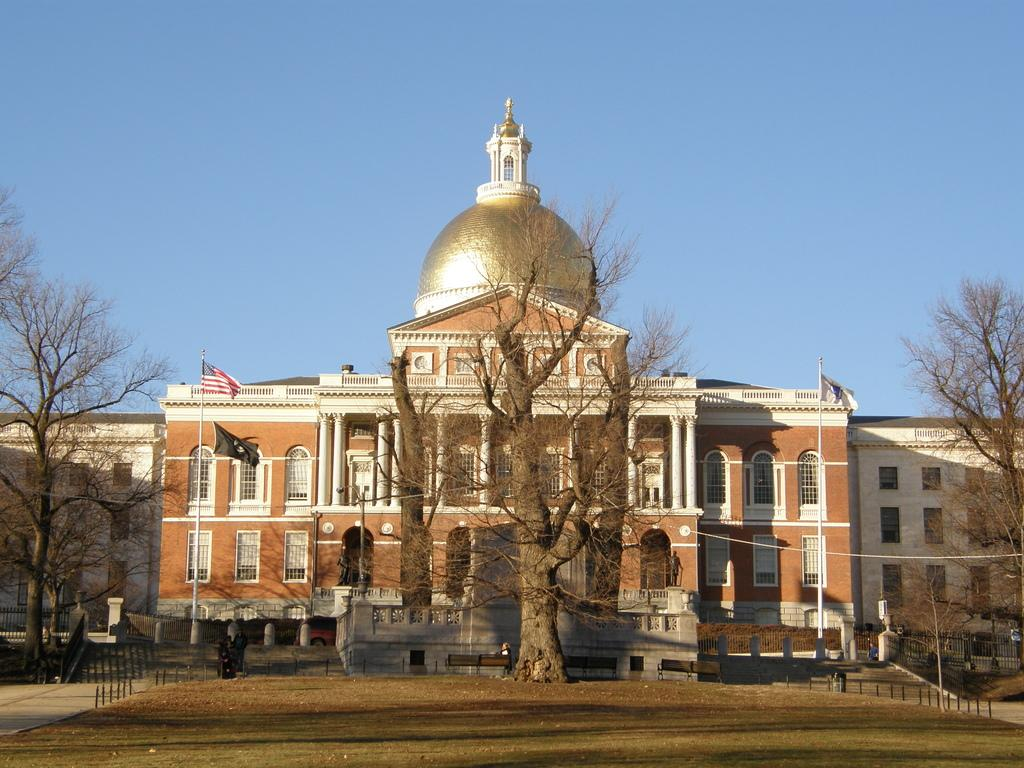What is the main structure in the center of the image? There is a building in the center of the image. What type of vegetation can be seen on both sides of the image? There are trees on both the right and left sides of the image. What is located on the left side of the image, besides the trees? There is a flag on the left side of the image. What type of bait is being used to catch the stranger in the image? There is no bait or stranger present in the image. Can you tell me what kind of pet is visible in the image? There is no pet visible in the image. 